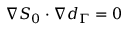Convert formula to latex. <formula><loc_0><loc_0><loc_500><loc_500>\nabla S _ { 0 } \cdot \nabla d _ { \Gamma } = 0</formula> 